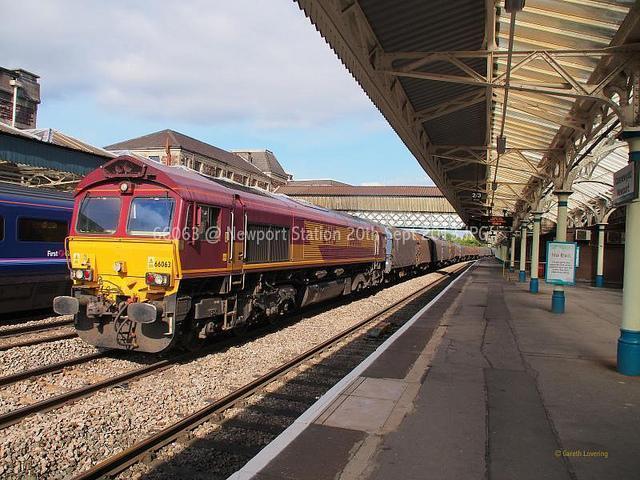How many trains are there?
Give a very brief answer. 2. 